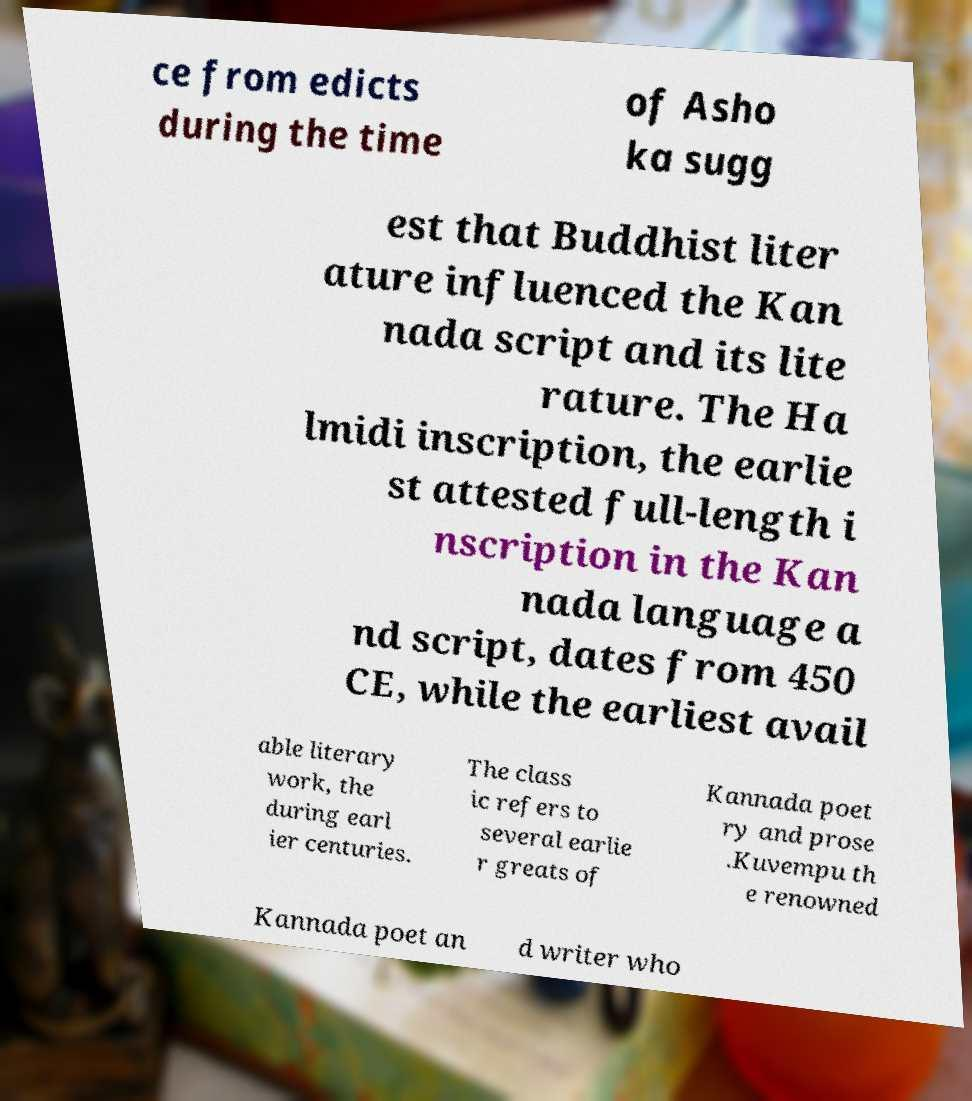Can you accurately transcribe the text from the provided image for me? ce from edicts during the time of Asho ka sugg est that Buddhist liter ature influenced the Kan nada script and its lite rature. The Ha lmidi inscription, the earlie st attested full-length i nscription in the Kan nada language a nd script, dates from 450 CE, while the earliest avail able literary work, the during earl ier centuries. The class ic refers to several earlie r greats of Kannada poet ry and prose .Kuvempu th e renowned Kannada poet an d writer who 